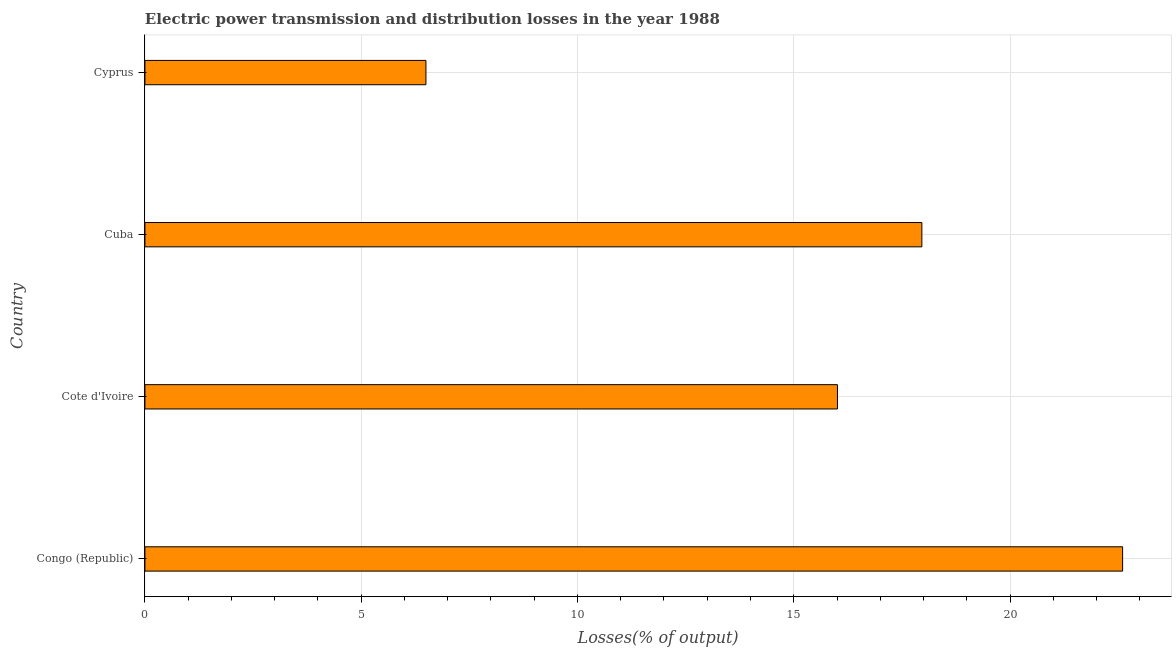What is the title of the graph?
Keep it short and to the point. Electric power transmission and distribution losses in the year 1988. What is the label or title of the X-axis?
Give a very brief answer. Losses(% of output). What is the label or title of the Y-axis?
Offer a terse response. Country. What is the electric power transmission and distribution losses in Cote d'Ivoire?
Keep it short and to the point. 16.01. Across all countries, what is the maximum electric power transmission and distribution losses?
Provide a succinct answer. 22.6. Across all countries, what is the minimum electric power transmission and distribution losses?
Your answer should be very brief. 6.5. In which country was the electric power transmission and distribution losses maximum?
Your answer should be compact. Congo (Republic). In which country was the electric power transmission and distribution losses minimum?
Keep it short and to the point. Cyprus. What is the sum of the electric power transmission and distribution losses?
Ensure brevity in your answer.  63.07. What is the difference between the electric power transmission and distribution losses in Congo (Republic) and Cuba?
Your answer should be compact. 4.64. What is the average electric power transmission and distribution losses per country?
Give a very brief answer. 15.77. What is the median electric power transmission and distribution losses?
Provide a succinct answer. 16.99. What is the ratio of the electric power transmission and distribution losses in Cuba to that in Cyprus?
Make the answer very short. 2.77. Is the electric power transmission and distribution losses in Cote d'Ivoire less than that in Cyprus?
Keep it short and to the point. No. Is the difference between the electric power transmission and distribution losses in Cuba and Cyprus greater than the difference between any two countries?
Provide a short and direct response. No. What is the difference between the highest and the second highest electric power transmission and distribution losses?
Provide a succinct answer. 4.64. What is the difference between the highest and the lowest electric power transmission and distribution losses?
Make the answer very short. 16.11. Are all the bars in the graph horizontal?
Provide a short and direct response. Yes. What is the difference between two consecutive major ticks on the X-axis?
Your answer should be very brief. 5. Are the values on the major ticks of X-axis written in scientific E-notation?
Provide a succinct answer. No. What is the Losses(% of output) of Congo (Republic)?
Your answer should be compact. 22.6. What is the Losses(% of output) in Cote d'Ivoire?
Provide a short and direct response. 16.01. What is the Losses(% of output) in Cuba?
Your answer should be very brief. 17.96. What is the Losses(% of output) of Cyprus?
Your answer should be compact. 6.5. What is the difference between the Losses(% of output) in Congo (Republic) and Cote d'Ivoire?
Keep it short and to the point. 6.59. What is the difference between the Losses(% of output) in Congo (Republic) and Cuba?
Provide a succinct answer. 4.64. What is the difference between the Losses(% of output) in Congo (Republic) and Cyprus?
Offer a very short reply. 16.11. What is the difference between the Losses(% of output) in Cote d'Ivoire and Cuba?
Your answer should be compact. -1.95. What is the difference between the Losses(% of output) in Cote d'Ivoire and Cyprus?
Your answer should be compact. 9.51. What is the difference between the Losses(% of output) in Cuba and Cyprus?
Provide a short and direct response. 11.47. What is the ratio of the Losses(% of output) in Congo (Republic) to that in Cote d'Ivoire?
Ensure brevity in your answer.  1.41. What is the ratio of the Losses(% of output) in Congo (Republic) to that in Cuba?
Your answer should be very brief. 1.26. What is the ratio of the Losses(% of output) in Congo (Republic) to that in Cyprus?
Offer a very short reply. 3.48. What is the ratio of the Losses(% of output) in Cote d'Ivoire to that in Cuba?
Offer a terse response. 0.89. What is the ratio of the Losses(% of output) in Cote d'Ivoire to that in Cyprus?
Your response must be concise. 2.46. What is the ratio of the Losses(% of output) in Cuba to that in Cyprus?
Offer a very short reply. 2.77. 